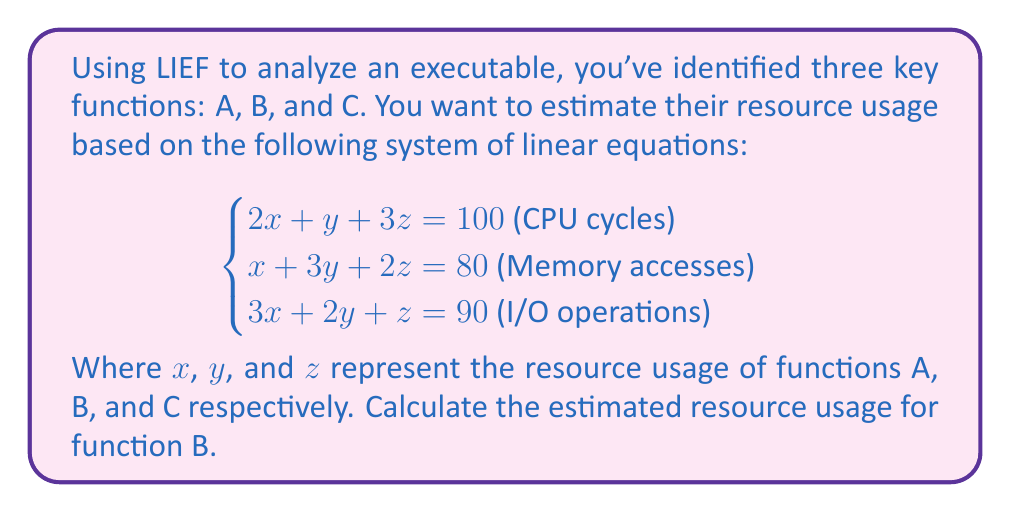What is the answer to this math problem? To solve this system of linear equations, we'll use the elimination method:

1) Multiply the first equation by 3 and the third equation by -2:
   $$\begin{cases}
   6x + 3y + 9z = 300 \\
   x + 3y + 2z = 80 \\
   -6x - 4y - 2z = -180
   \end{cases}$$

2) Add these equations to eliminate x:
   $$-y + 7z = 200$$

3) Multiply the second equation by 3 and the new equation by 1:
   $$\begin{cases}
   3x + 9y + 6z = 240 \\
   -y + 7z = 200
   \end{cases}$$

4) Add these equations to eliminate y:
   $$3x + 13z = 440$$

5) Multiply the original second equation by 3 and this new equation by -1:
   $$\begin{cases}
   3x + 9y + 6z = 240 \\
   -3x - 13z = -440
   \end{cases}$$

6) Add these equations:
   $$9y - 7z = -200$$

7) Now we have two equations with two unknowns:
   $$\begin{cases}
   -y + 7z = 200 \\
   9y - 7z = -200
   \end{cases}$$

8) Add these equations:
   $$8y = 0$$
   $$y = 0$$

9) Substitute this back into $-y + 7z = 200$:
   $$7z = 200$$
   $$z = \frac{200}{7} \approx 28.57$$

10) Substitute y and z into the original second equation:
    $$x + 3(0) + 2(28.57) = 80$$
    $$x + 57.14 = 80$$
    $$x = 22.86$$

Therefore, $y = 0$, which represents the resource usage of function B.
Answer: 0 